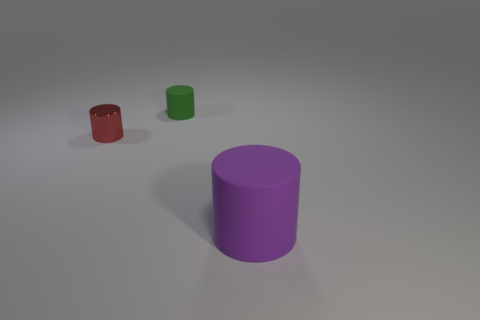Subtract all brown cylinders. Subtract all blue balls. How many cylinders are left? 3 Add 3 tiny cylinders. How many objects exist? 6 Add 1 small red cylinders. How many small red cylinders exist? 2 Subtract 0 green balls. How many objects are left? 3 Subtract all purple rubber objects. Subtract all small objects. How many objects are left? 0 Add 1 small rubber objects. How many small rubber objects are left? 2 